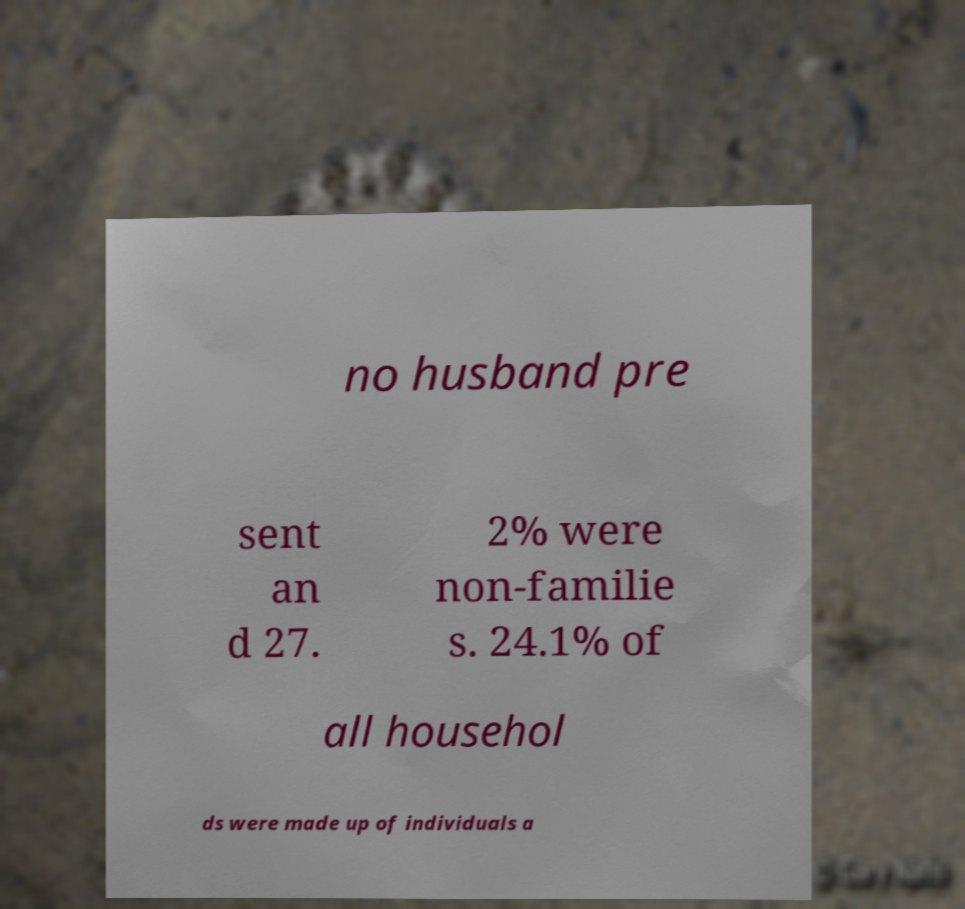Please identify and transcribe the text found in this image. no husband pre sent an d 27. 2% were non-familie s. 24.1% of all househol ds were made up of individuals a 